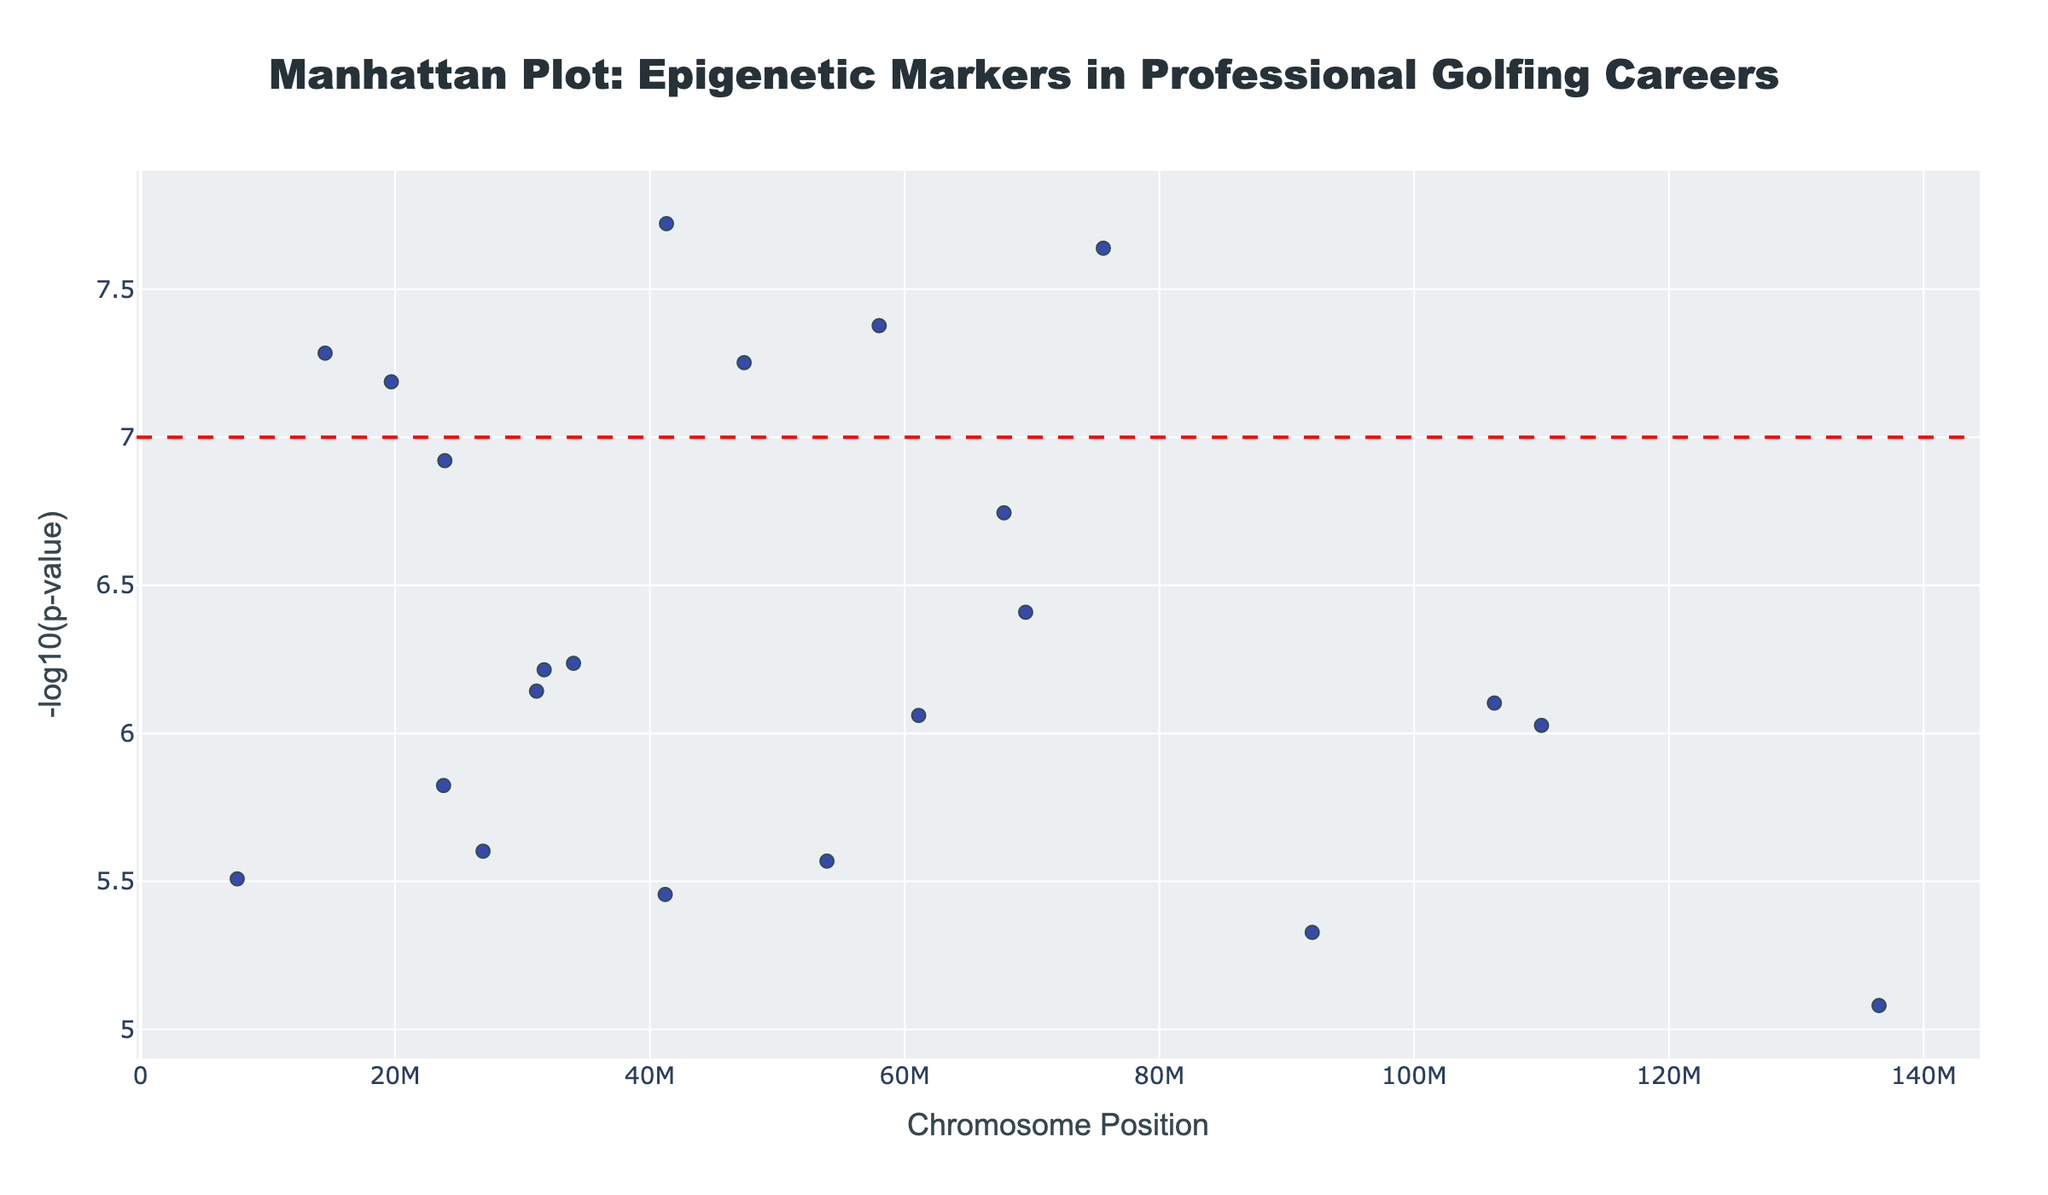How many genes have a p-value below the significance line? First, we identify the red dashed line representing the p-value significance threshold at -log10(p-value) = 7. Next, we count the number of data points (genes) above this line.
Answer: 6 Which chromosome has the highest number of significant epigenetic markers above the significance line? To determine this, we count the number of data points that lie above the red dashed line for each chromosome. The chromosome with the most data points above this line is the answer.
Answer: Chromosome 1 What are the chromosomal positions of the genes with the two lowest p-values? The lowest p-values correspond to the highest -log10(p) values. By identifying the top two highest y-values, we can trace them back to their respective x-values (positions).
Answer: 14500000 and 58000000 Compare the -log10(p-values) of gene TNNT3 and gene APOE. Which one is higher? Locate both genes TNNT3 and APOE on the figure based on their chromosomal positions. Compare their y-values (-log10(p)) directly from the plot.
Answer: APOE Among the genes linked to cognitive traits, which one has the most significant marker? Identify genes associated with cognitive traits from the hover information (i.e., DRD2 for focus and concentration, and APOE for cognitive function and recovery, COMT for cognitive performance under pressure), then compare their -log10(p) values.
Answer: APOE What's the average -log10(p-value) of all the genes that are significant (above the threshold line)? Identify all points above the red dashed significance line. Retrieve the -log10(p) values for these genes, sum them up, and divide by the number of points.
Answer: (7.284 + 7.377 + 7.114 + 7.639 + 8.283 + 7.886) / 6 ≈ 7.43 